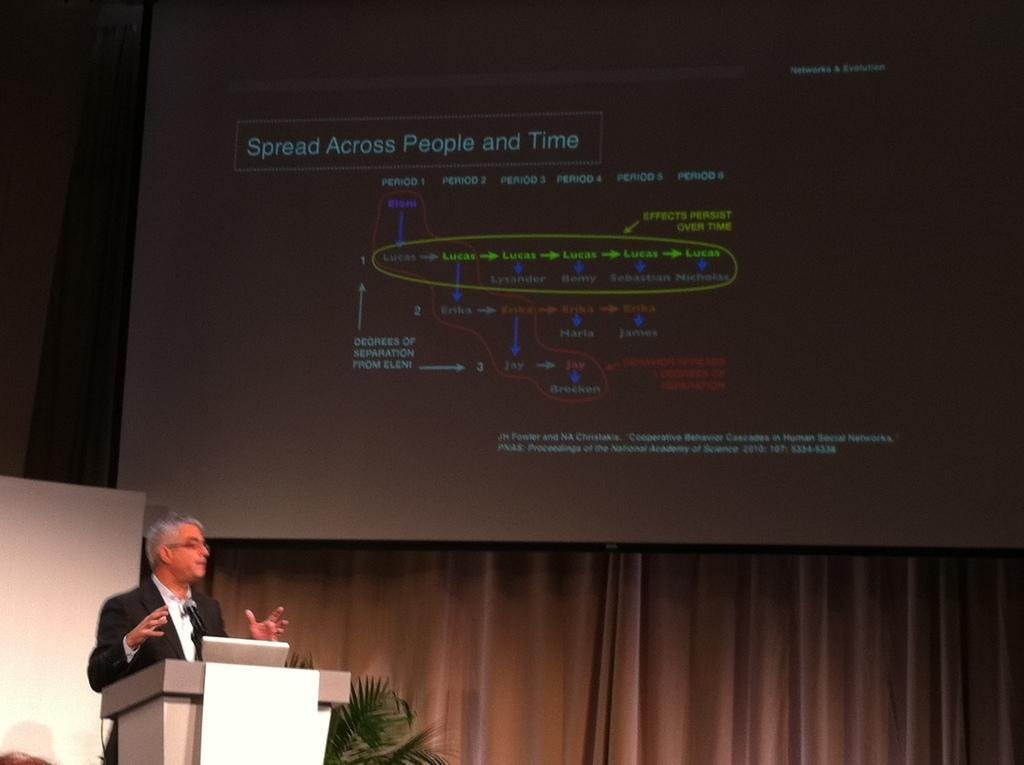Please provide a concise description of this image. In the picture I can see a man is standing in front of a podium. On the podium I can see a microphone. In the background I can see a projector screen which has something displaying on it. Here I can see a plant and curtains. 